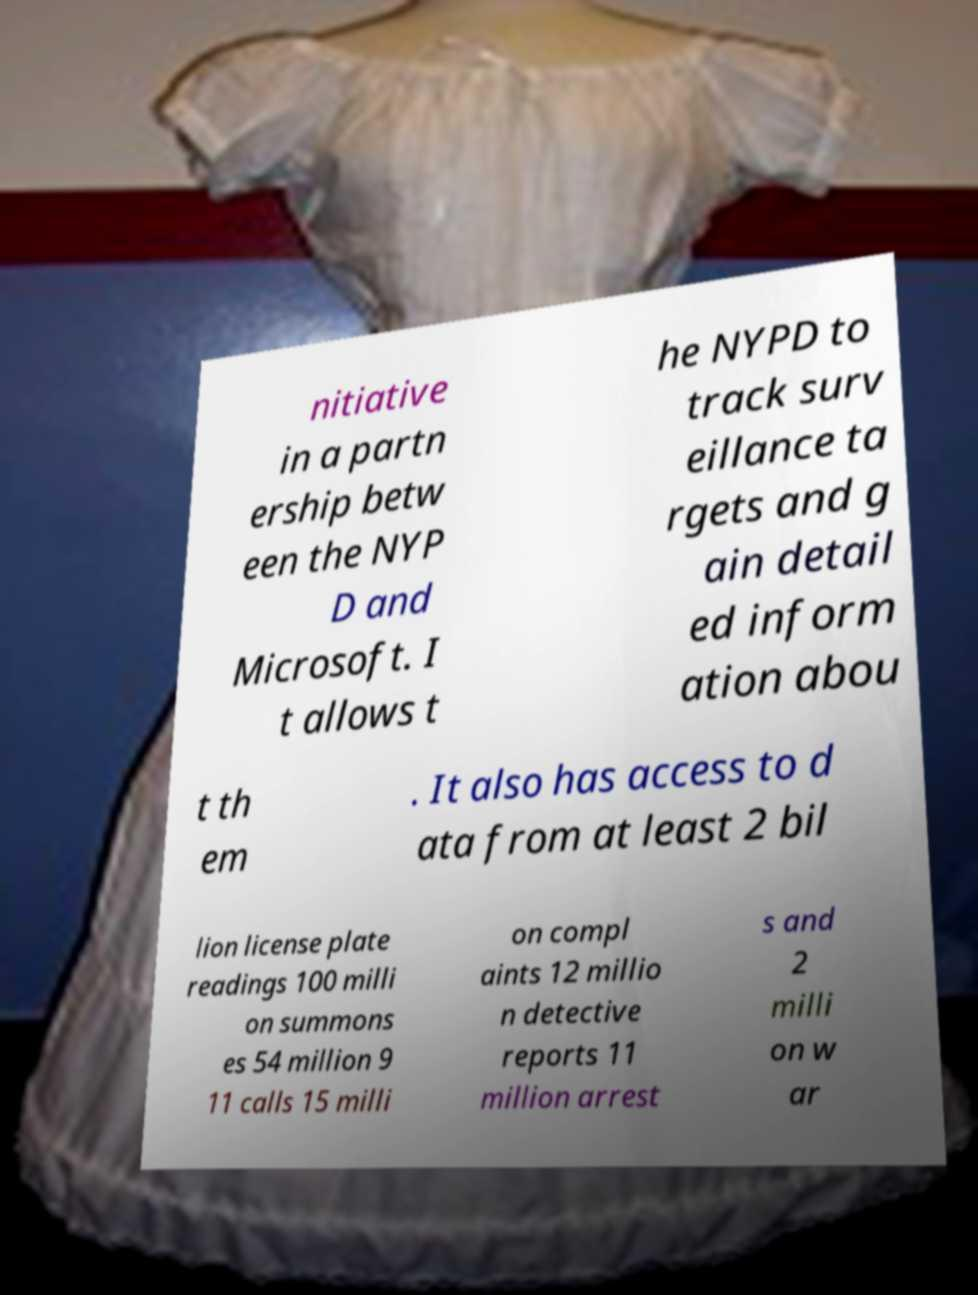Can you read and provide the text displayed in the image?This photo seems to have some interesting text. Can you extract and type it out for me? nitiative in a partn ership betw een the NYP D and Microsoft. I t allows t he NYPD to track surv eillance ta rgets and g ain detail ed inform ation abou t th em . It also has access to d ata from at least 2 bil lion license plate readings 100 milli on summons es 54 million 9 11 calls 15 milli on compl aints 12 millio n detective reports 11 million arrest s and 2 milli on w ar 